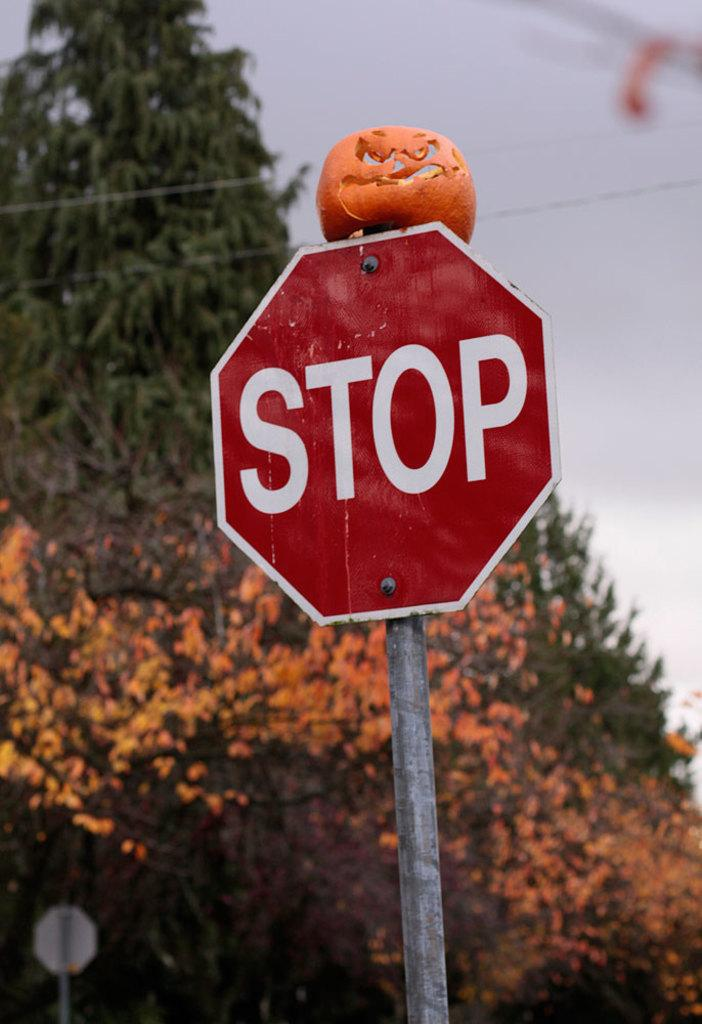<image>
Describe the image concisely. A red and white stop sign with a pumpkin displayed on top of it. 